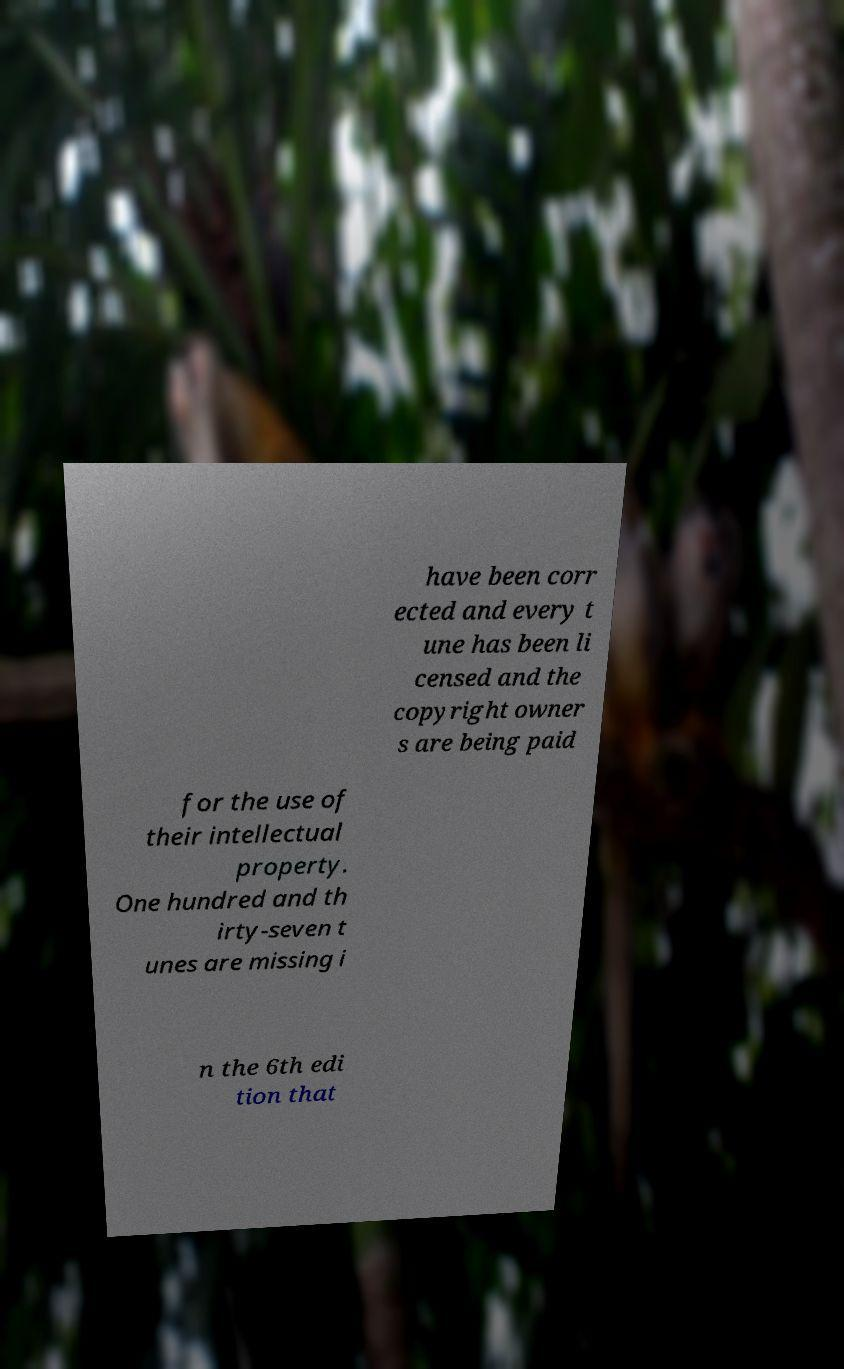Could you extract and type out the text from this image? have been corr ected and every t une has been li censed and the copyright owner s are being paid for the use of their intellectual property. One hundred and th irty-seven t unes are missing i n the 6th edi tion that 